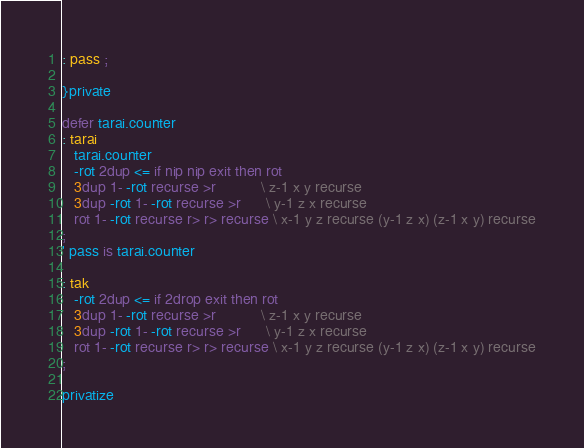Convert code to text. <code><loc_0><loc_0><loc_500><loc_500><_Forth_>
: pass ;

}private

defer tarai.counter
: tarai
   tarai.counter
   -rot 2dup <= if nip nip exit then rot
   3dup 1- -rot recurse >r           \ z-1 x y recurse
   3dup -rot 1- -rot recurse >r      \ y-1 z x recurse
   rot 1- -rot recurse r> r> recurse \ x-1 y z recurse (y-1 z x) (z-1 x y) recurse
;
' pass is tarai.counter

: tak
   -rot 2dup <= if 2drop exit then rot
   3dup 1- -rot recurse >r           \ z-1 x y recurse
   3dup -rot 1- -rot recurse >r      \ y-1 z x recurse
   rot 1- -rot recurse r> r> recurse \ x-1 y z recurse (y-1 z x) (z-1 x y) recurse
;

privatize
</code> 